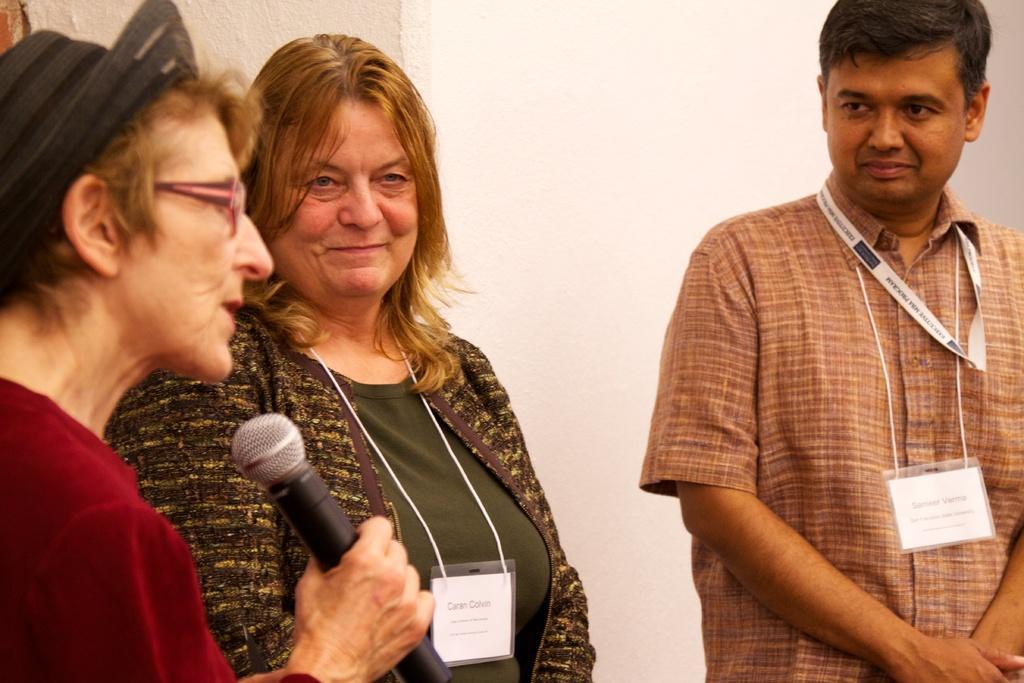Describe this image in one or two sentences. In this picture there are three people. The lady to the left of the image is holding a mic in her hand talking. The rest of the two guys have a white color id card in their neck. The background is white in color. 